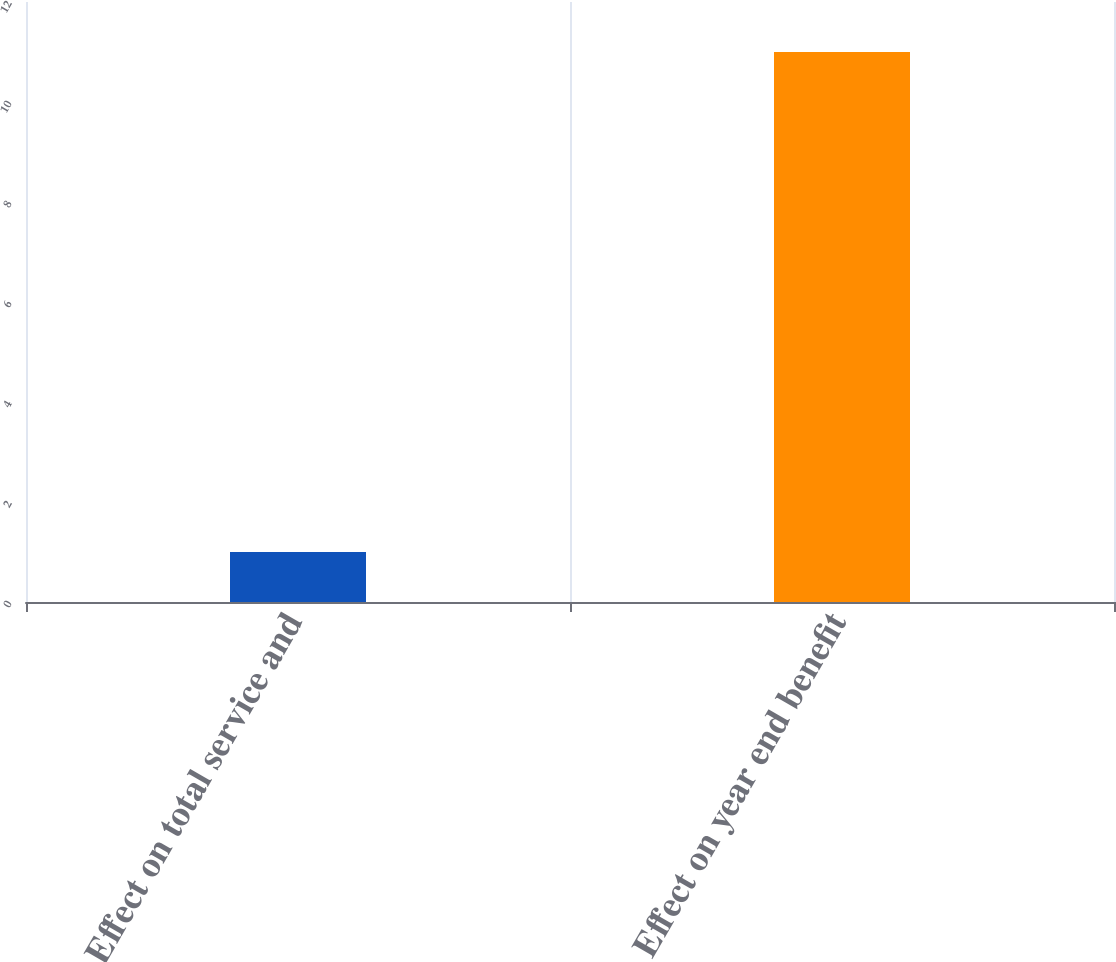Convert chart to OTSL. <chart><loc_0><loc_0><loc_500><loc_500><bar_chart><fcel>Effect on total service and<fcel>Effect on year end benefit<nl><fcel>1<fcel>11<nl></chart> 